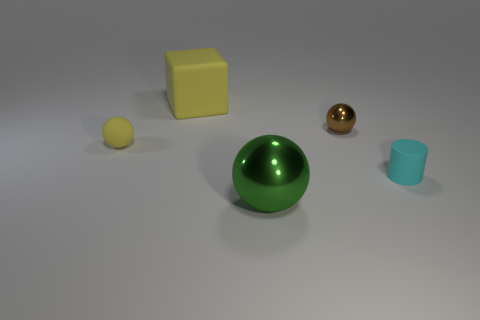How many blue things are large metal spheres or matte cubes?
Provide a succinct answer. 0. The sphere that is the same color as the rubber cube is what size?
Your answer should be compact. Small. Is the number of yellow things greater than the number of rubber objects?
Your answer should be compact. No. Does the matte sphere have the same color as the big matte thing?
Offer a terse response. Yes. How many things are rubber blocks or things that are right of the cube?
Provide a succinct answer. 4. How many other objects are the same shape as the big green shiny thing?
Make the answer very short. 2. Is the number of large shiny spheres in front of the cube less than the number of things that are behind the small yellow rubber thing?
Your answer should be very brief. Yes. There is a small cyan object that is made of the same material as the tiny yellow thing; what shape is it?
Give a very brief answer. Cylinder. Is there any other thing of the same color as the tiny matte ball?
Ensure brevity in your answer.  Yes. There is a tiny rubber object that is left of the big object that is behind the rubber ball; what is its color?
Keep it short and to the point. Yellow. 